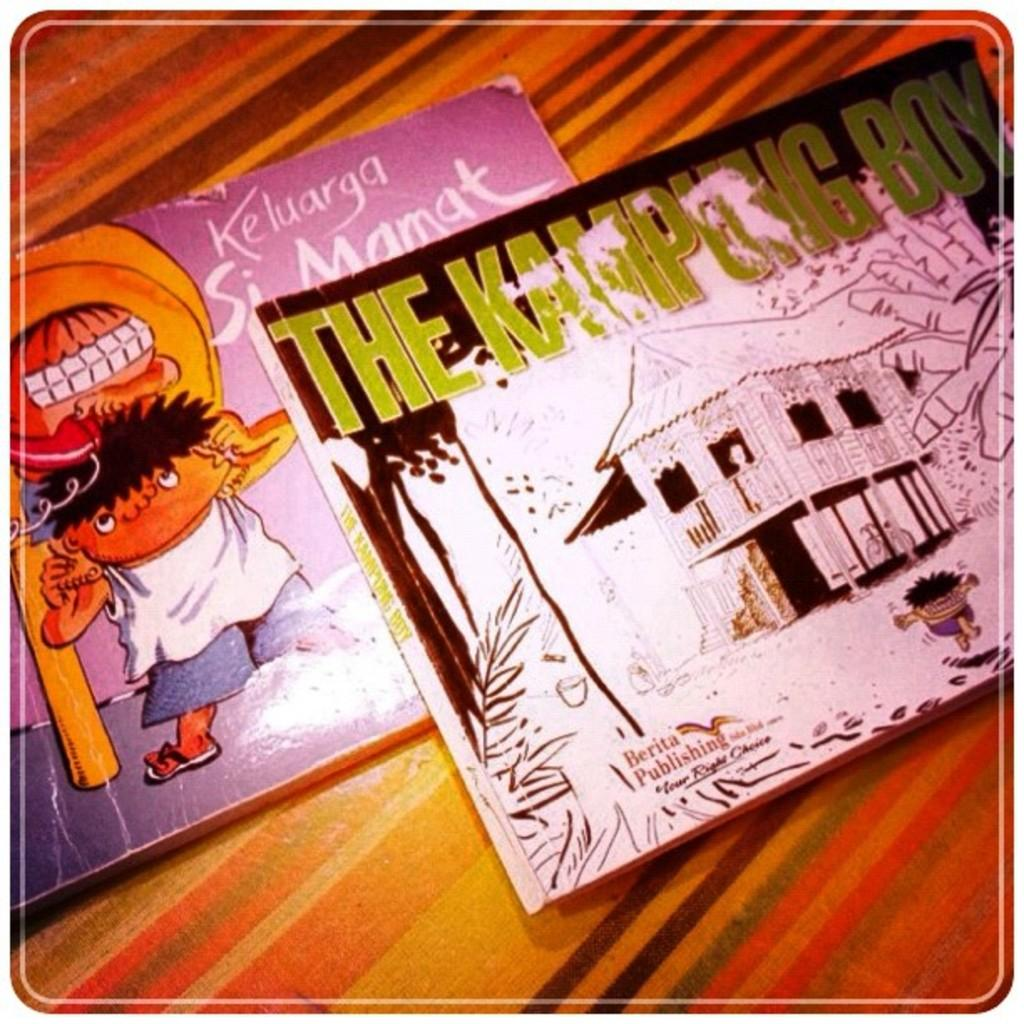<image>
Write a terse but informative summary of the picture. The Kampung Boy and Keluarga Si Mamat comic books on a table 